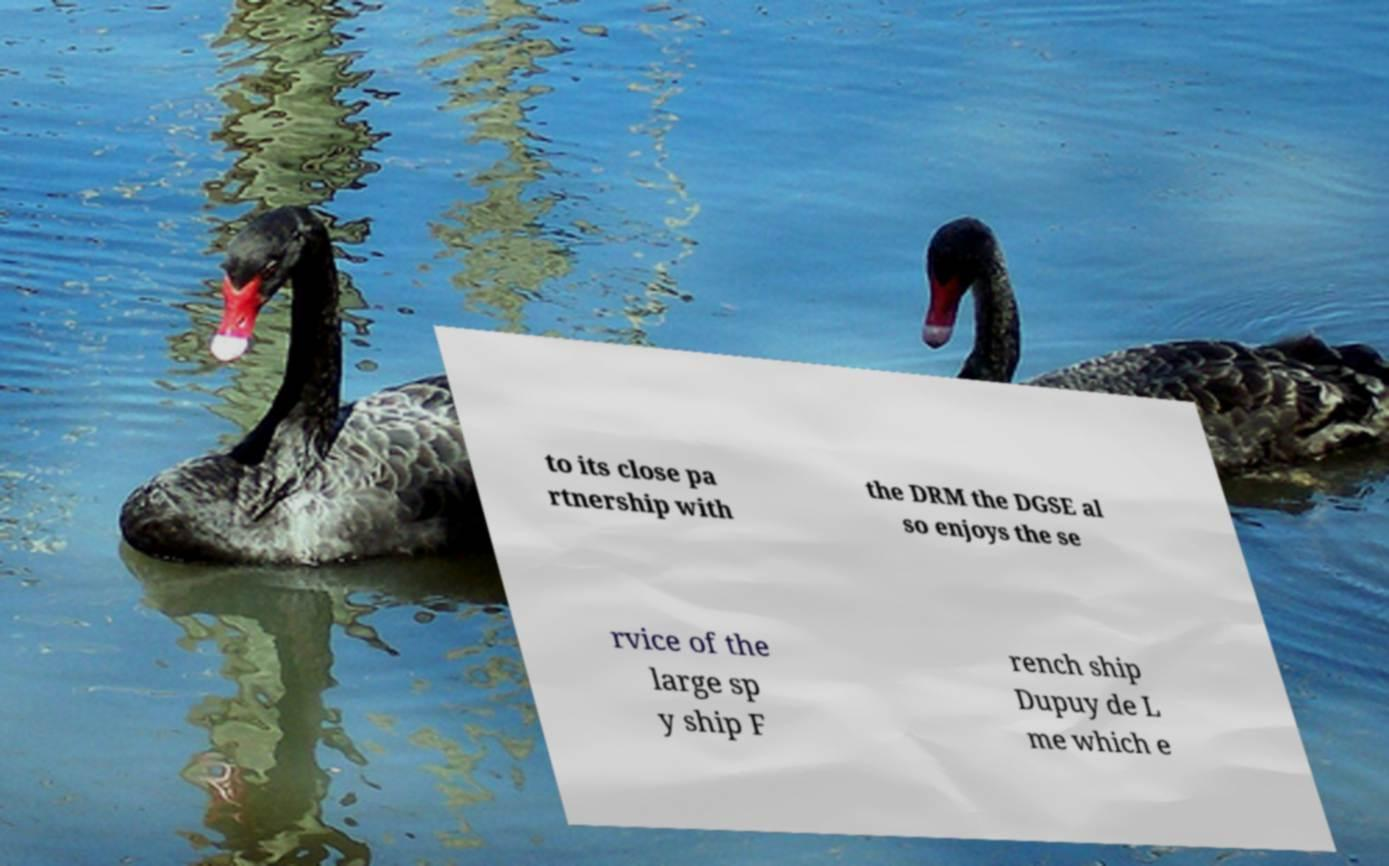Could you assist in decoding the text presented in this image and type it out clearly? to its close pa rtnership with the DRM the DGSE al so enjoys the se rvice of the large sp y ship F rench ship Dupuy de L me which e 